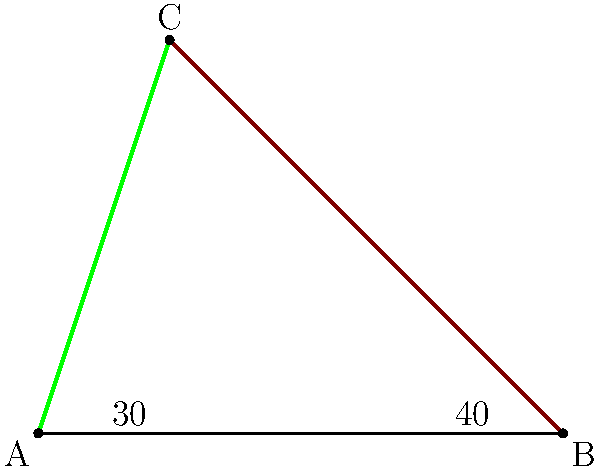In this diagram representing two intersecting tree branches, the angle between the ground and the green branch is 30°, while the angle between the ground and the brown branch is 40°. What is the angle formed between these two branches? To find the angle between the two branches, we can follow these steps:

1) First, recall that when two lines intersect, the sum of the angles on one side of the point of intersection is always 180°.

2) In this case, we have three angles: the angle between the ground and the green branch (30°), the angle between the ground and the brown branch (40°), and the angle we're looking for (let's call it $x$).

3) We can set up an equation:
   $30° + 40° + x = 180°$

4) Simplify:
   $70° + x = 180°$

5) Subtract 70° from both sides:
   $x = 180° - 70° = 110°$

Therefore, the angle formed between the two branches is 110°.

This problem demonstrates how nature often follows mathematical principles, with tree branches growing at specific angles to maximize sunlight exposure and structural stability.
Answer: 110° 